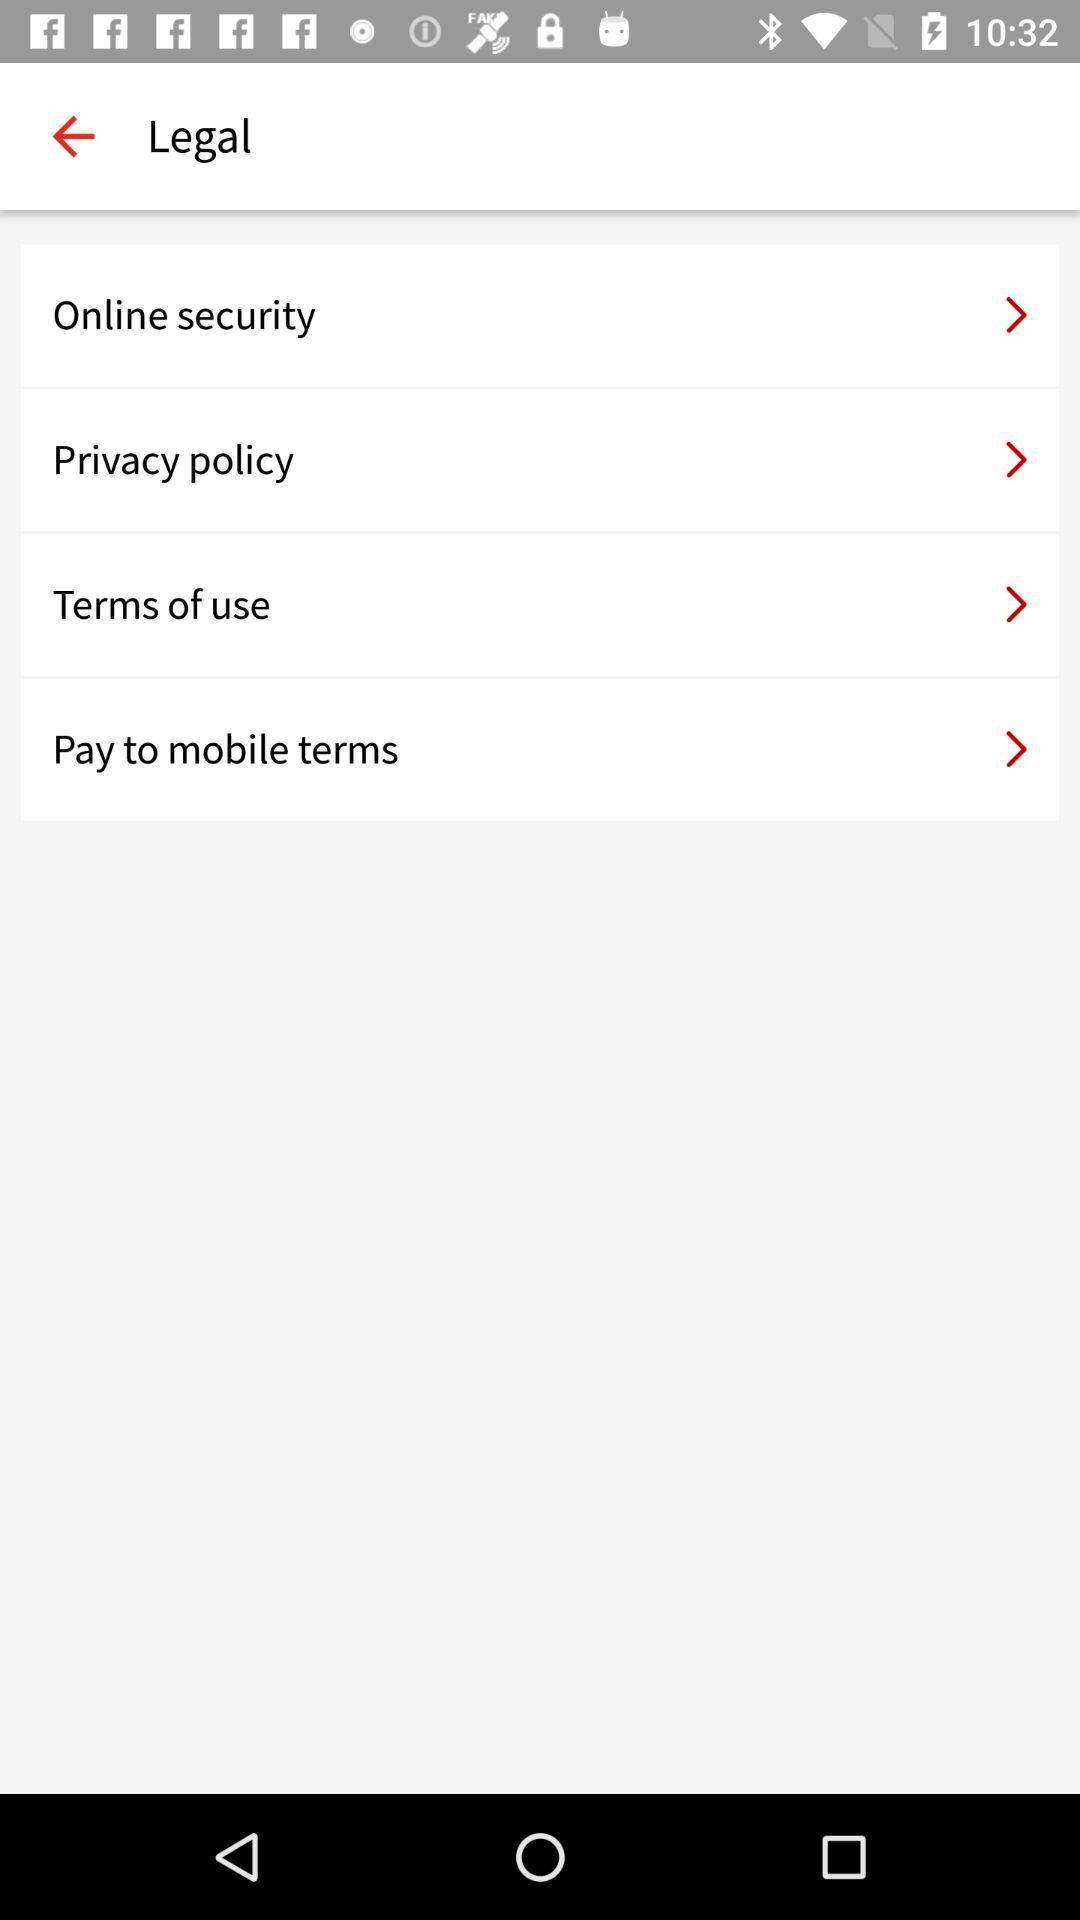What do these terms of service relate to? The terms of service depicted in the image appear to be related to a digital platform or application, possibly a financial service given the mention of 'Pay to mobile terms'. They dictate the legal agreements between the service provider and the user, outlining the rules for online security, privacy, use of service, and mobile payment transactions. 